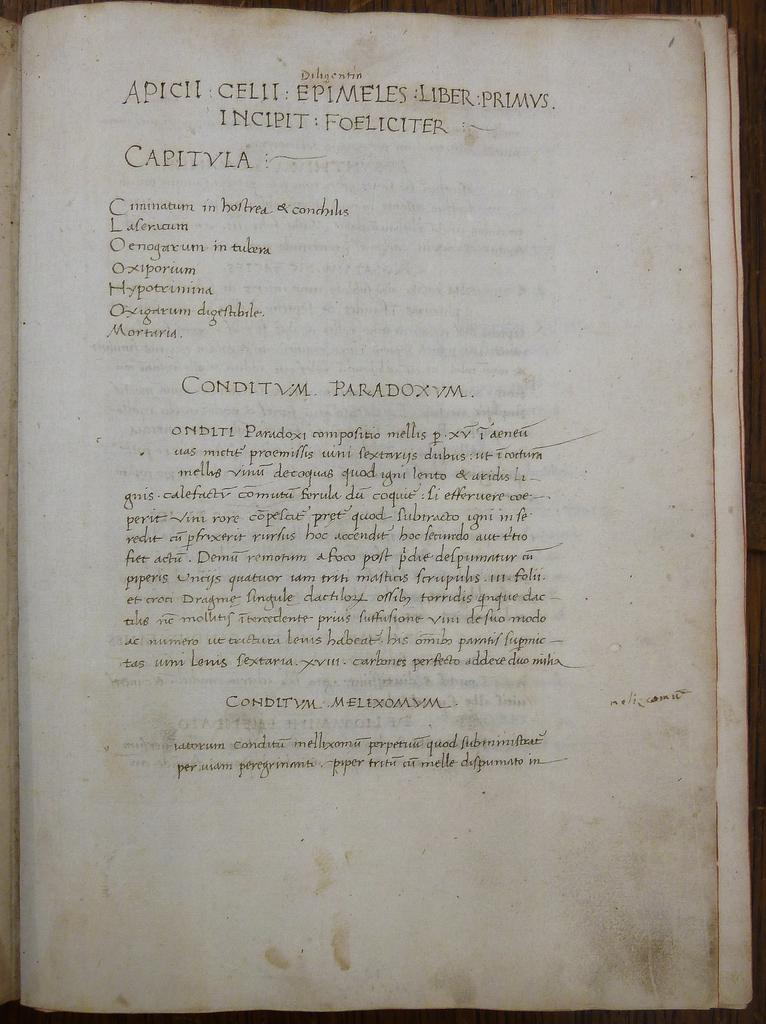<image>
Summarize the visual content of the image. An ancient book in another language has a section titled "Capitvla." 